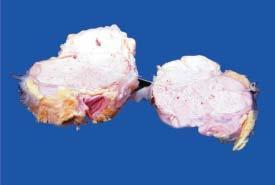where are areas of necrosis?
Answer the question using a single word or phrase. There in the circumscribed nodular areas 